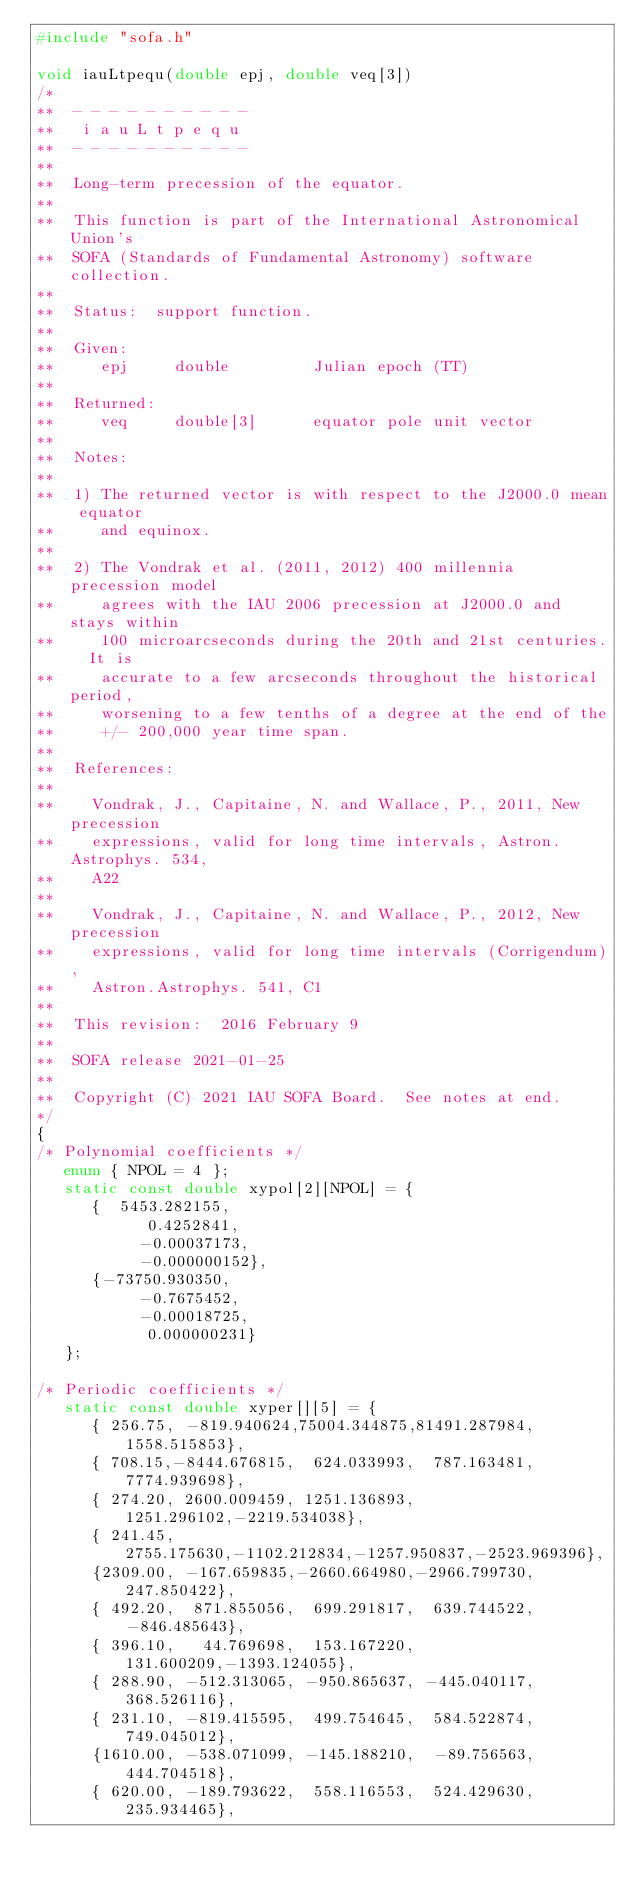<code> <loc_0><loc_0><loc_500><loc_500><_C_>#include "sofa.h"

void iauLtpequ(double epj, double veq[3])
/*
**  - - - - - - - - - -
**   i a u L t p e q u
**  - - - - - - - - - -
**
**  Long-term precession of the equator.
**
**  This function is part of the International Astronomical Union's
**  SOFA (Standards of Fundamental Astronomy) software collection.
**
**  Status:  support function.
**
**  Given:
**     epj     double         Julian epoch (TT)
**
**  Returned:
**     veq     double[3]      equator pole unit vector
**
**  Notes:
**
**  1) The returned vector is with respect to the J2000.0 mean equator
**     and equinox.
**
**  2) The Vondrak et al. (2011, 2012) 400 millennia precession model
**     agrees with the IAU 2006 precession at J2000.0 and stays within
**     100 microarcseconds during the 20th and 21st centuries.  It is
**     accurate to a few arcseconds throughout the historical period,
**     worsening to a few tenths of a degree at the end of the
**     +/- 200,000 year time span.
**
**  References:
**
**    Vondrak, J., Capitaine, N. and Wallace, P., 2011, New precession
**    expressions, valid for long time intervals, Astron.Astrophys. 534,
**    A22
**
**    Vondrak, J., Capitaine, N. and Wallace, P., 2012, New precession
**    expressions, valid for long time intervals (Corrigendum),
**    Astron.Astrophys. 541, C1
**
**  This revision:  2016 February 9
**
**  SOFA release 2021-01-25
**
**  Copyright (C) 2021 IAU SOFA Board.  See notes at end.
*/
{
/* Polynomial coefficients */
   enum { NPOL = 4 };
   static const double xypol[2][NPOL] = {
      {  5453.282155,
            0.4252841,
           -0.00037173,
           -0.000000152},
      {-73750.930350,
           -0.7675452,
           -0.00018725,
            0.000000231}
   };

/* Periodic coefficients */
   static const double xyper[][5] = {
      { 256.75, -819.940624,75004.344875,81491.287984, 1558.515853},
      { 708.15,-8444.676815,  624.033993,  787.163481, 7774.939698},
      { 274.20, 2600.009459, 1251.136893, 1251.296102,-2219.534038},
      { 241.45, 2755.175630,-1102.212834,-1257.950837,-2523.969396},
      {2309.00, -167.659835,-2660.664980,-2966.799730,  247.850422},
      { 492.20,  871.855056,  699.291817,  639.744522, -846.485643},
      { 396.10,   44.769698,  153.167220,  131.600209,-1393.124055},
      { 288.90, -512.313065, -950.865637, -445.040117,  368.526116},
      { 231.10, -819.415595,  499.754645,  584.522874,  749.045012},
      {1610.00, -538.071099, -145.188210,  -89.756563,  444.704518},
      { 620.00, -189.793622,  558.116553,  524.429630,  235.934465},</code> 